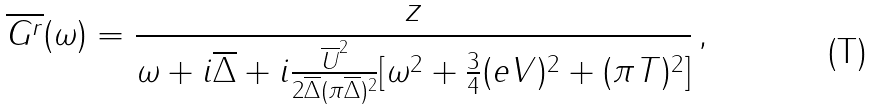<formula> <loc_0><loc_0><loc_500><loc_500>\overline { G ^ { r } } ( \omega ) = \frac { z } { \omega + i \overline { \Delta } + i \frac { \overline { U } ^ { 2 } } { 2 \overline { \Delta } ( \pi \overline { \Delta } ) ^ { 2 } } [ \omega ^ { 2 } + \frac { 3 } { 4 } ( e V ) ^ { 2 } + ( \pi T ) ^ { 2 } ] } \, ,</formula> 